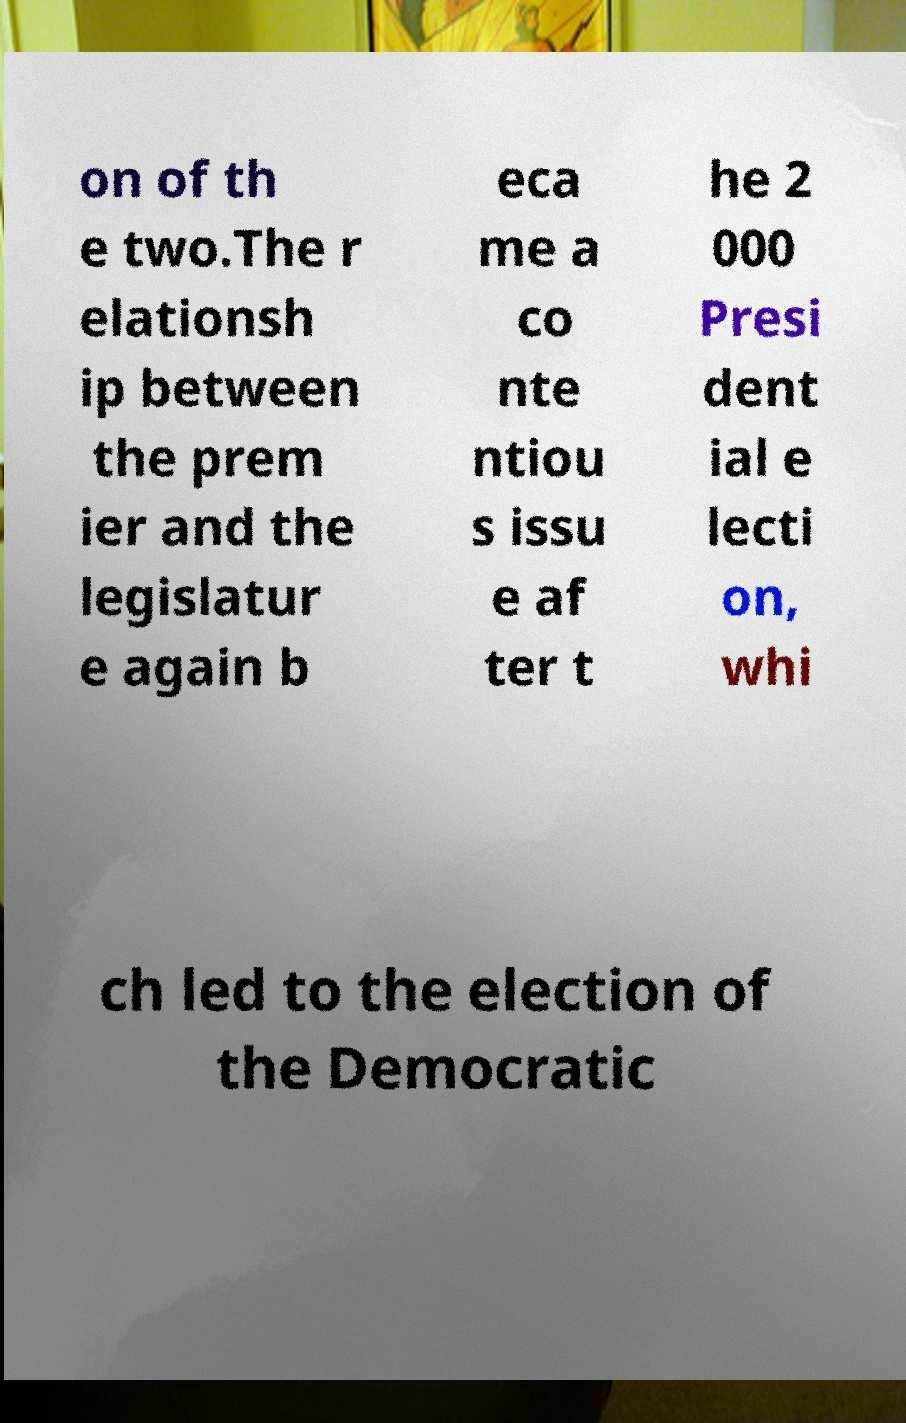Please identify and transcribe the text found in this image. on of th e two.The r elationsh ip between the prem ier and the legislatur e again b eca me a co nte ntiou s issu e af ter t he 2 000 Presi dent ial e lecti on, whi ch led to the election of the Democratic 